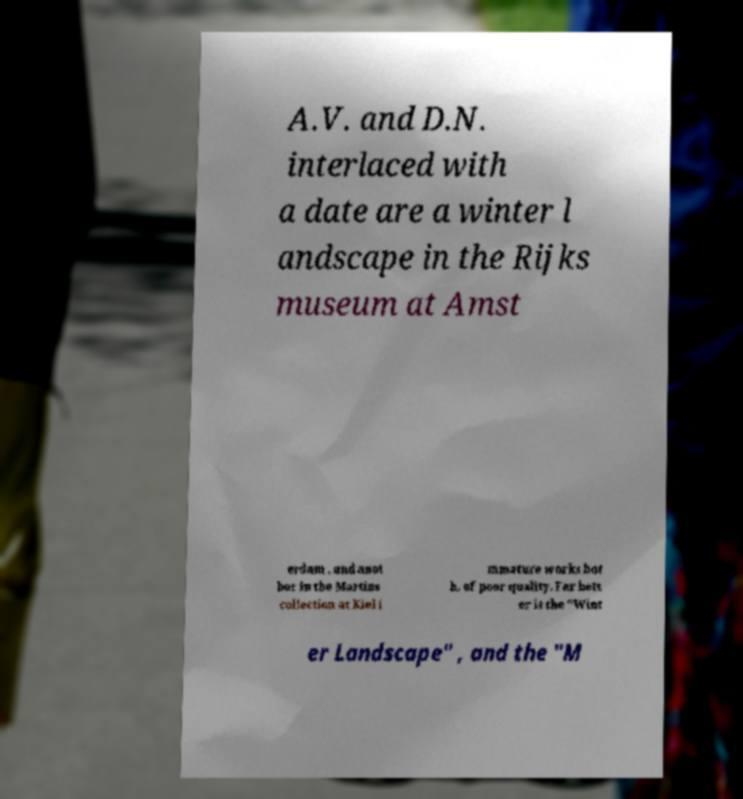I need the written content from this picture converted into text. Can you do that? A.V. and D.N. interlaced with a date are a winter l andscape in the Rijks museum at Amst erdam , and anot her in the Martins collection at Kiel i mmature works bot h, of poor quality. Far bett er is the "Wint er Landscape" , and the "M 